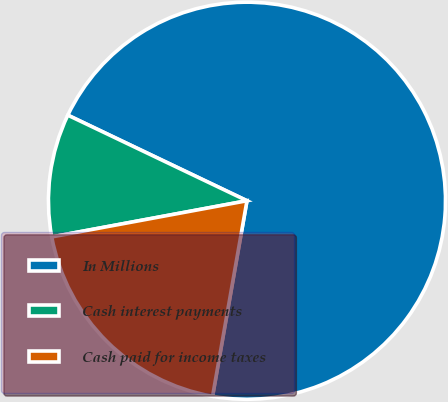Convert chart. <chart><loc_0><loc_0><loc_500><loc_500><pie_chart><fcel>In Millions<fcel>Cash interest payments<fcel>Cash paid for income taxes<nl><fcel>70.68%<fcel>10.01%<fcel>19.31%<nl></chart> 